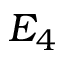Convert formula to latex. <formula><loc_0><loc_0><loc_500><loc_500>E _ { 4 }</formula> 